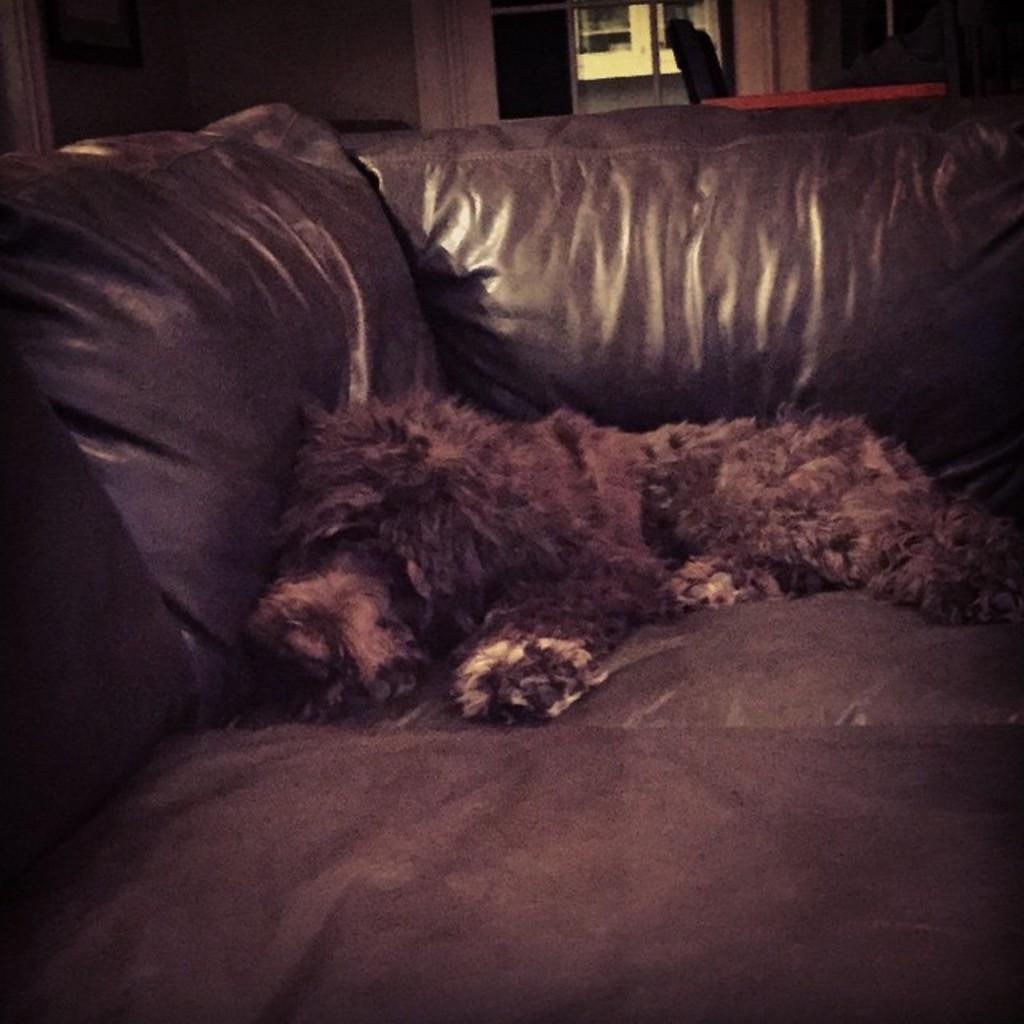What animal can be seen in the image? There is a dog in the image. What is the dog doing in the image? The dog is sleeping on the couch. What can be seen in the background of the image? There is a door visible in the background of the image. What is the frame at the top of the image attached to? The frame is attached to a wall. Can you see any pickles in the image? There are no pickles present in the image. Is the dog in the image exploring a cave? There is no cave present in the image; the dog is sleeping on the couch. 